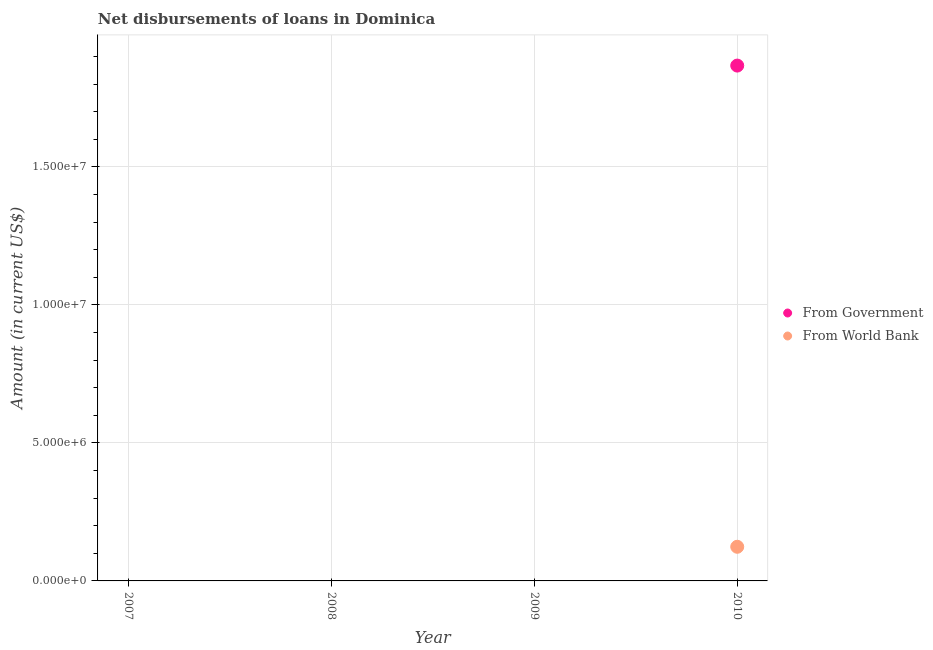Is the number of dotlines equal to the number of legend labels?
Make the answer very short. No. What is the net disbursements of loan from government in 2008?
Your response must be concise. 0. Across all years, what is the maximum net disbursements of loan from government?
Offer a very short reply. 1.87e+07. In which year was the net disbursements of loan from government maximum?
Make the answer very short. 2010. What is the total net disbursements of loan from government in the graph?
Make the answer very short. 1.87e+07. What is the average net disbursements of loan from government per year?
Provide a short and direct response. 4.67e+06. In the year 2010, what is the difference between the net disbursements of loan from world bank and net disbursements of loan from government?
Give a very brief answer. -1.74e+07. In how many years, is the net disbursements of loan from world bank greater than 7000000 US$?
Provide a succinct answer. 0. What is the difference between the highest and the lowest net disbursements of loan from world bank?
Your answer should be very brief. 1.24e+06. In how many years, is the net disbursements of loan from world bank greater than the average net disbursements of loan from world bank taken over all years?
Ensure brevity in your answer.  1. Does the net disbursements of loan from government monotonically increase over the years?
Ensure brevity in your answer.  No. How many years are there in the graph?
Give a very brief answer. 4. What is the difference between two consecutive major ticks on the Y-axis?
Provide a succinct answer. 5.00e+06. How many legend labels are there?
Your answer should be very brief. 2. How are the legend labels stacked?
Ensure brevity in your answer.  Vertical. What is the title of the graph?
Make the answer very short. Net disbursements of loans in Dominica. Does "Fertility rate" appear as one of the legend labels in the graph?
Offer a terse response. No. What is the label or title of the Y-axis?
Your response must be concise. Amount (in current US$). What is the Amount (in current US$) of From World Bank in 2009?
Your answer should be compact. 0. What is the Amount (in current US$) of From Government in 2010?
Provide a short and direct response. 1.87e+07. What is the Amount (in current US$) of From World Bank in 2010?
Provide a short and direct response. 1.24e+06. Across all years, what is the maximum Amount (in current US$) of From Government?
Provide a succinct answer. 1.87e+07. Across all years, what is the maximum Amount (in current US$) of From World Bank?
Offer a very short reply. 1.24e+06. Across all years, what is the minimum Amount (in current US$) in From Government?
Your answer should be compact. 0. Across all years, what is the minimum Amount (in current US$) of From World Bank?
Your answer should be very brief. 0. What is the total Amount (in current US$) in From Government in the graph?
Provide a succinct answer. 1.87e+07. What is the total Amount (in current US$) of From World Bank in the graph?
Give a very brief answer. 1.24e+06. What is the average Amount (in current US$) of From Government per year?
Your response must be concise. 4.67e+06. What is the average Amount (in current US$) of From World Bank per year?
Offer a terse response. 3.09e+05. In the year 2010, what is the difference between the Amount (in current US$) of From Government and Amount (in current US$) of From World Bank?
Your answer should be very brief. 1.74e+07. What is the difference between the highest and the lowest Amount (in current US$) of From Government?
Provide a short and direct response. 1.87e+07. What is the difference between the highest and the lowest Amount (in current US$) of From World Bank?
Give a very brief answer. 1.24e+06. 